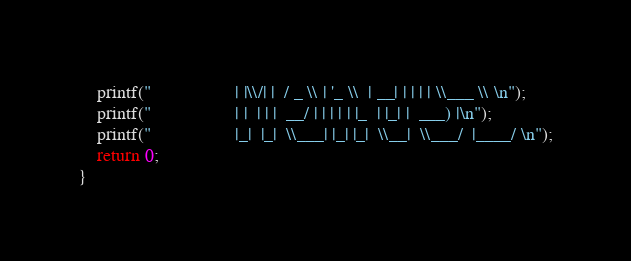<code> <loc_0><loc_0><loc_500><loc_500><_C_>    printf("                  | |\\/| |  / _ \\ | '_ \\  | __| | | | | \\___ \\ \n");
    printf("                  | |  | | |  __/ | | | | | |_  | |_| |  ___) |\n");
    printf("                  |_|  |_|  \\___| |_| |_|  \\__|  \\___/  |____/ \n");
    return 0;
}
</code> 